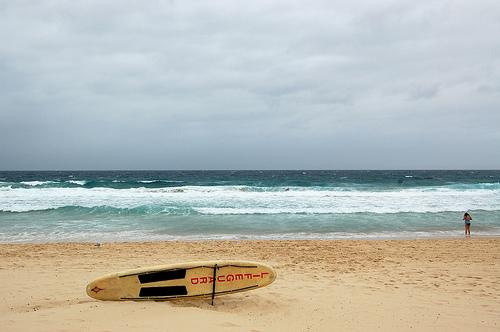Is the sun shining?
Short answer required. No. What color is the surfboard?
Quick response, please. Yellow. Is there a bonfire in the photo?
Concise answer only. No. Will it rain soon?
Quick response, please. Yes. What vehicle is parked in front of the rock?
Quick response, please. Surfboard. Where is the surfboard?
Be succinct. Beach. 